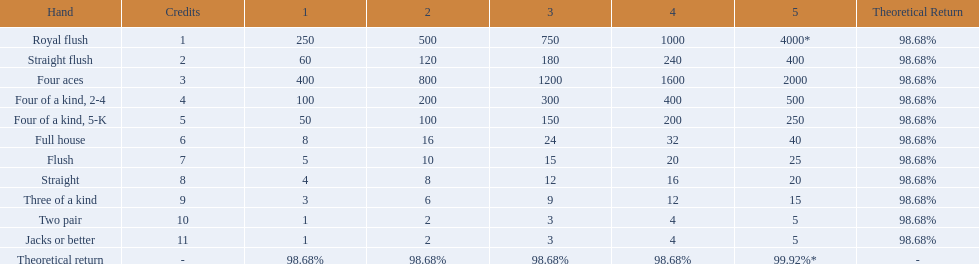Which hand is the third best hand in the card game super aces? Four aces. Which hand is the second best hand? Straight flush. Which hand had is the best hand? Royal flush. 